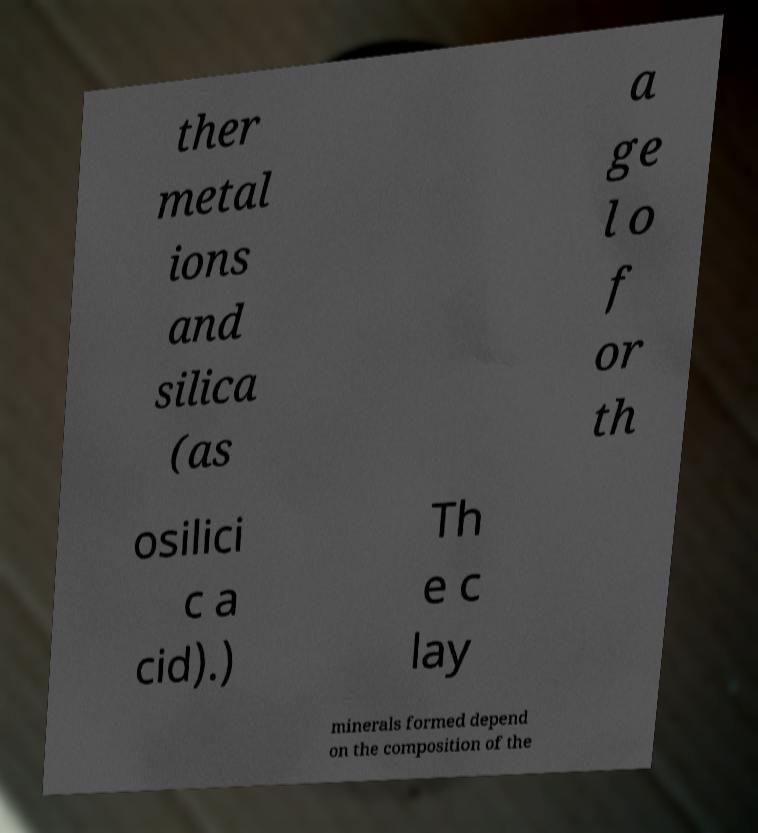Please read and relay the text visible in this image. What does it say? ther metal ions and silica (as a ge l o f or th osilici c a cid).) Th e c lay minerals formed depend on the composition of the 